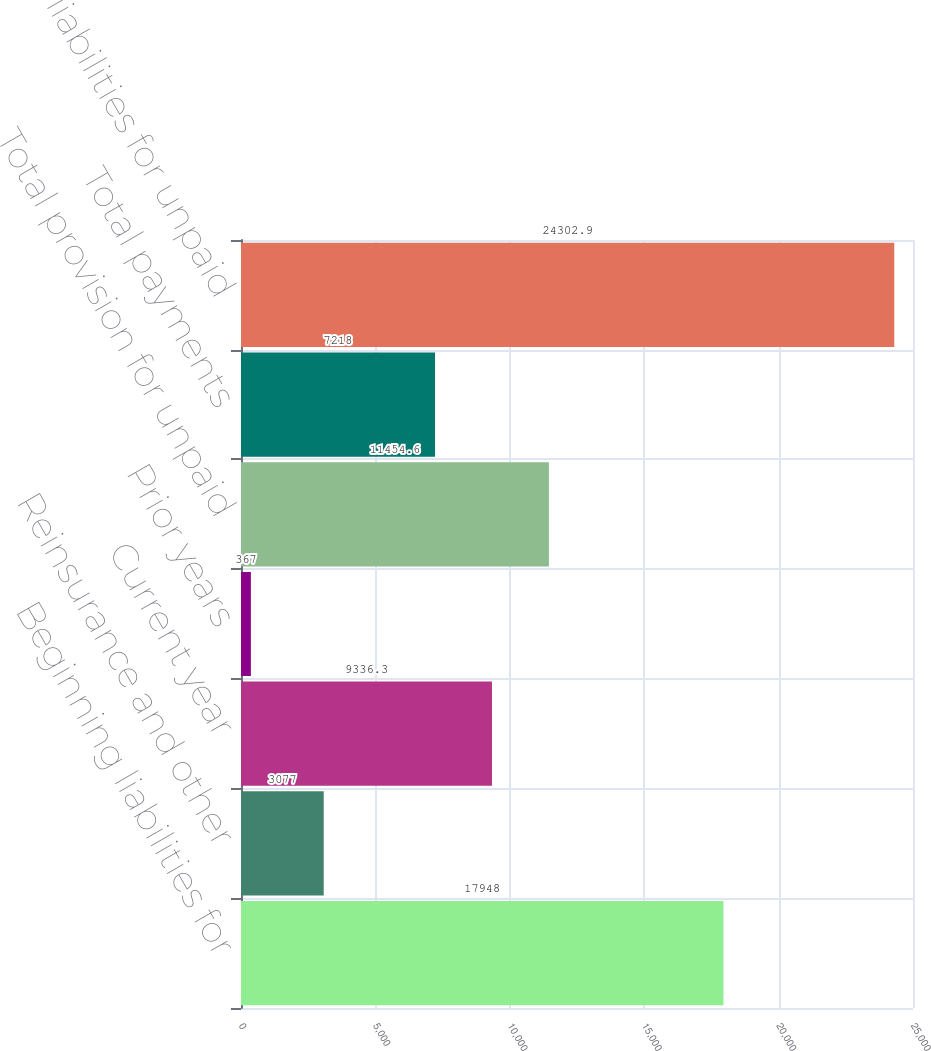Convert chart. <chart><loc_0><loc_0><loc_500><loc_500><bar_chart><fcel>Beginning liabilities for<fcel>Reinsurance and other<fcel>Current year<fcel>Prior years<fcel>Total provision for unpaid<fcel>Total payments<fcel>Ending liabilities for unpaid<nl><fcel>17948<fcel>3077<fcel>9336.3<fcel>367<fcel>11454.6<fcel>7218<fcel>24302.9<nl></chart> 